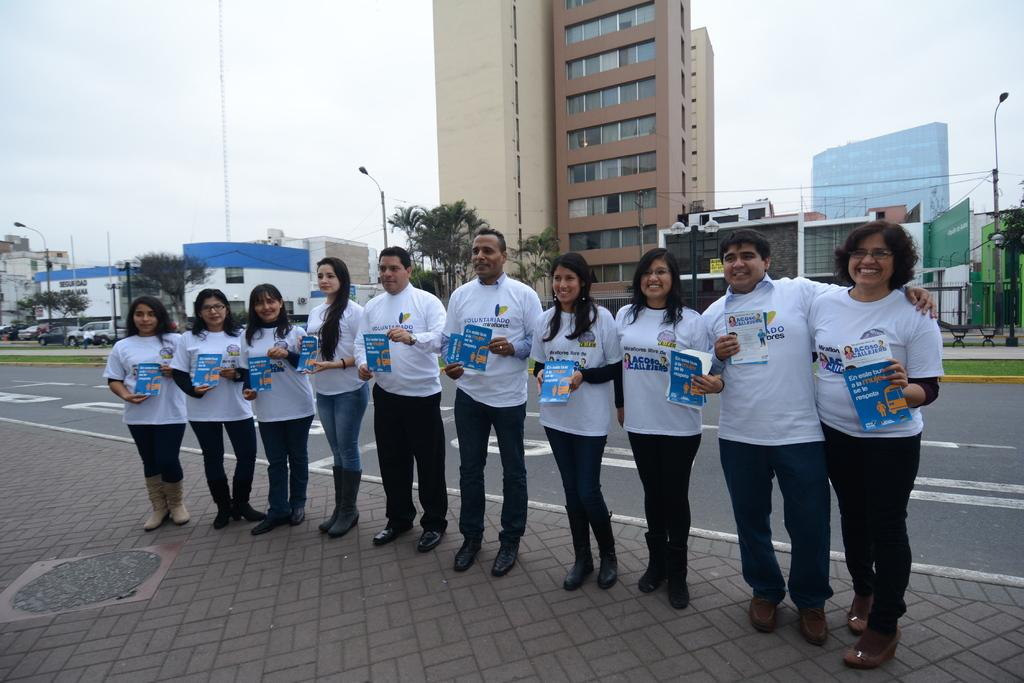What is happening in the foreground of the image? There is a group of persons standing on the road. What can be seen in the background of the image? There are buildings, trees, poles, fencing, a tower, and the sky visible in the background of the image. What type of rings are the persons wearing in the image? There is no mention of rings or any jewelry in the image. The focus is on the group of persons standing on the road and the background elements. 